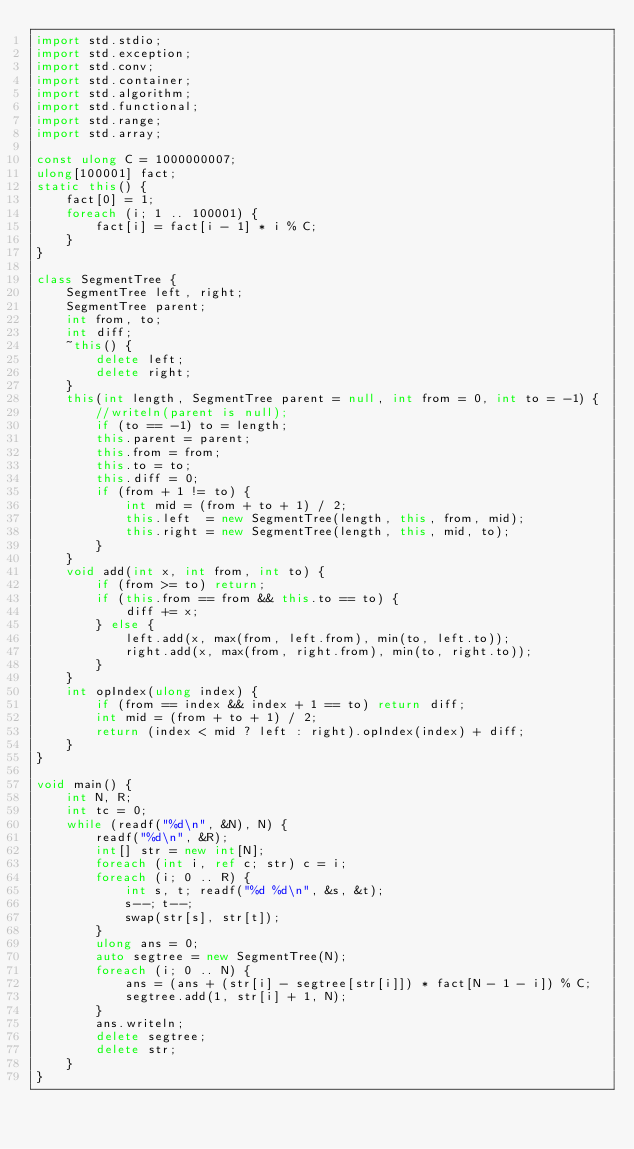Convert code to text. <code><loc_0><loc_0><loc_500><loc_500><_D_>import std.stdio;
import std.exception;
import std.conv;
import std.container;
import std.algorithm;
import std.functional;
import std.range;
import std.array;

const ulong C = 1000000007;
ulong[100001] fact;
static this() {
    fact[0] = 1;
    foreach (i; 1 .. 100001) {
        fact[i] = fact[i - 1] * i % C;
    }
}

class SegmentTree {
    SegmentTree left, right; 
    SegmentTree parent;
    int from, to;
    int diff;
    ~this() {
        delete left;
        delete right;
    }
    this(int length, SegmentTree parent = null, int from = 0, int to = -1) {
        //writeln(parent is null);
        if (to == -1) to = length;
        this.parent = parent;
        this.from = from;
        this.to = to;
        this.diff = 0;
        if (from + 1 != to) {
            int mid = (from + to + 1) / 2;
            this.left  = new SegmentTree(length, this, from, mid);
            this.right = new SegmentTree(length, this, mid, to);
        }
    }
    void add(int x, int from, int to) {
        if (from >= to) return;
        if (this.from == from && this.to == to) {
            diff += x;
        } else {
            left.add(x, max(from, left.from), min(to, left.to));
            right.add(x, max(from, right.from), min(to, right.to));
        }
    }
    int opIndex(ulong index) {
        if (from == index && index + 1 == to) return diff;
        int mid = (from + to + 1) / 2;
        return (index < mid ? left : right).opIndex(index) + diff;
    }
}

void main() {
    int N, R;
    int tc = 0;
    while (readf("%d\n", &N), N) {
        readf("%d\n", &R);
        int[] str = new int[N];
        foreach (int i, ref c; str) c = i;
        foreach (i; 0 .. R) {
            int s, t; readf("%d %d\n", &s, &t);
            s--; t--;
            swap(str[s], str[t]);
        }
        ulong ans = 0;
        auto segtree = new SegmentTree(N);
        foreach (i; 0 .. N) {
            ans = (ans + (str[i] - segtree[str[i]]) * fact[N - 1 - i]) % C;
            segtree.add(1, str[i] + 1, N);
        }
        ans.writeln;
        delete segtree;
        delete str;
    }
}</code> 